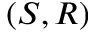<formula> <loc_0><loc_0><loc_500><loc_500>( S , R )</formula> 